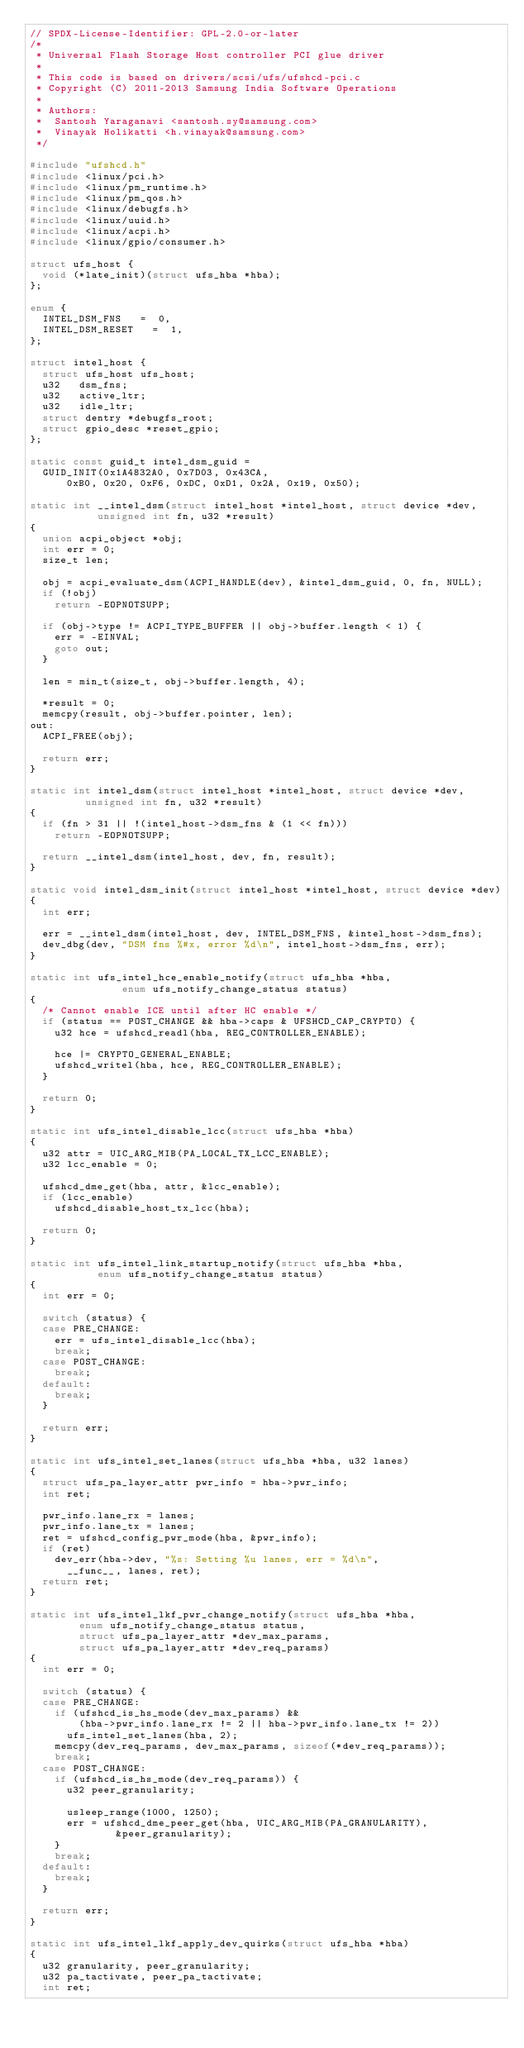<code> <loc_0><loc_0><loc_500><loc_500><_C_>// SPDX-License-Identifier: GPL-2.0-or-later
/*
 * Universal Flash Storage Host controller PCI glue driver
 *
 * This code is based on drivers/scsi/ufs/ufshcd-pci.c
 * Copyright (C) 2011-2013 Samsung India Software Operations
 *
 * Authors:
 *	Santosh Yaraganavi <santosh.sy@samsung.com>
 *	Vinayak Holikatti <h.vinayak@samsung.com>
 */

#include "ufshcd.h"
#include <linux/pci.h>
#include <linux/pm_runtime.h>
#include <linux/pm_qos.h>
#include <linux/debugfs.h>
#include <linux/uuid.h>
#include <linux/acpi.h>
#include <linux/gpio/consumer.h>

struct ufs_host {
	void (*late_init)(struct ufs_hba *hba);
};

enum {
	INTEL_DSM_FNS		=  0,
	INTEL_DSM_RESET		=  1,
};

struct intel_host {
	struct ufs_host ufs_host;
	u32		dsm_fns;
	u32		active_ltr;
	u32		idle_ltr;
	struct dentry	*debugfs_root;
	struct gpio_desc *reset_gpio;
};

static const guid_t intel_dsm_guid =
	GUID_INIT(0x1A4832A0, 0x7D03, 0x43CA,
		  0xB0, 0x20, 0xF6, 0xDC, 0xD1, 0x2A, 0x19, 0x50);

static int __intel_dsm(struct intel_host *intel_host, struct device *dev,
		       unsigned int fn, u32 *result)
{
	union acpi_object *obj;
	int err = 0;
	size_t len;

	obj = acpi_evaluate_dsm(ACPI_HANDLE(dev), &intel_dsm_guid, 0, fn, NULL);
	if (!obj)
		return -EOPNOTSUPP;

	if (obj->type != ACPI_TYPE_BUFFER || obj->buffer.length < 1) {
		err = -EINVAL;
		goto out;
	}

	len = min_t(size_t, obj->buffer.length, 4);

	*result = 0;
	memcpy(result, obj->buffer.pointer, len);
out:
	ACPI_FREE(obj);

	return err;
}

static int intel_dsm(struct intel_host *intel_host, struct device *dev,
		     unsigned int fn, u32 *result)
{
	if (fn > 31 || !(intel_host->dsm_fns & (1 << fn)))
		return -EOPNOTSUPP;

	return __intel_dsm(intel_host, dev, fn, result);
}

static void intel_dsm_init(struct intel_host *intel_host, struct device *dev)
{
	int err;

	err = __intel_dsm(intel_host, dev, INTEL_DSM_FNS, &intel_host->dsm_fns);
	dev_dbg(dev, "DSM fns %#x, error %d\n", intel_host->dsm_fns, err);
}

static int ufs_intel_hce_enable_notify(struct ufs_hba *hba,
				       enum ufs_notify_change_status status)
{
	/* Cannot enable ICE until after HC enable */
	if (status == POST_CHANGE && hba->caps & UFSHCD_CAP_CRYPTO) {
		u32 hce = ufshcd_readl(hba, REG_CONTROLLER_ENABLE);

		hce |= CRYPTO_GENERAL_ENABLE;
		ufshcd_writel(hba, hce, REG_CONTROLLER_ENABLE);
	}

	return 0;
}

static int ufs_intel_disable_lcc(struct ufs_hba *hba)
{
	u32 attr = UIC_ARG_MIB(PA_LOCAL_TX_LCC_ENABLE);
	u32 lcc_enable = 0;

	ufshcd_dme_get(hba, attr, &lcc_enable);
	if (lcc_enable)
		ufshcd_disable_host_tx_lcc(hba);

	return 0;
}

static int ufs_intel_link_startup_notify(struct ufs_hba *hba,
					 enum ufs_notify_change_status status)
{
	int err = 0;

	switch (status) {
	case PRE_CHANGE:
		err = ufs_intel_disable_lcc(hba);
		break;
	case POST_CHANGE:
		break;
	default:
		break;
	}

	return err;
}

static int ufs_intel_set_lanes(struct ufs_hba *hba, u32 lanes)
{
	struct ufs_pa_layer_attr pwr_info = hba->pwr_info;
	int ret;

	pwr_info.lane_rx = lanes;
	pwr_info.lane_tx = lanes;
	ret = ufshcd_config_pwr_mode(hba, &pwr_info);
	if (ret)
		dev_err(hba->dev, "%s: Setting %u lanes, err = %d\n",
			__func__, lanes, ret);
	return ret;
}

static int ufs_intel_lkf_pwr_change_notify(struct ufs_hba *hba,
				enum ufs_notify_change_status status,
				struct ufs_pa_layer_attr *dev_max_params,
				struct ufs_pa_layer_attr *dev_req_params)
{
	int err = 0;

	switch (status) {
	case PRE_CHANGE:
		if (ufshcd_is_hs_mode(dev_max_params) &&
		    (hba->pwr_info.lane_rx != 2 || hba->pwr_info.lane_tx != 2))
			ufs_intel_set_lanes(hba, 2);
		memcpy(dev_req_params, dev_max_params, sizeof(*dev_req_params));
		break;
	case POST_CHANGE:
		if (ufshcd_is_hs_mode(dev_req_params)) {
			u32 peer_granularity;

			usleep_range(1000, 1250);
			err = ufshcd_dme_peer_get(hba, UIC_ARG_MIB(PA_GRANULARITY),
						  &peer_granularity);
		}
		break;
	default:
		break;
	}

	return err;
}

static int ufs_intel_lkf_apply_dev_quirks(struct ufs_hba *hba)
{
	u32 granularity, peer_granularity;
	u32 pa_tactivate, peer_pa_tactivate;
	int ret;
</code> 